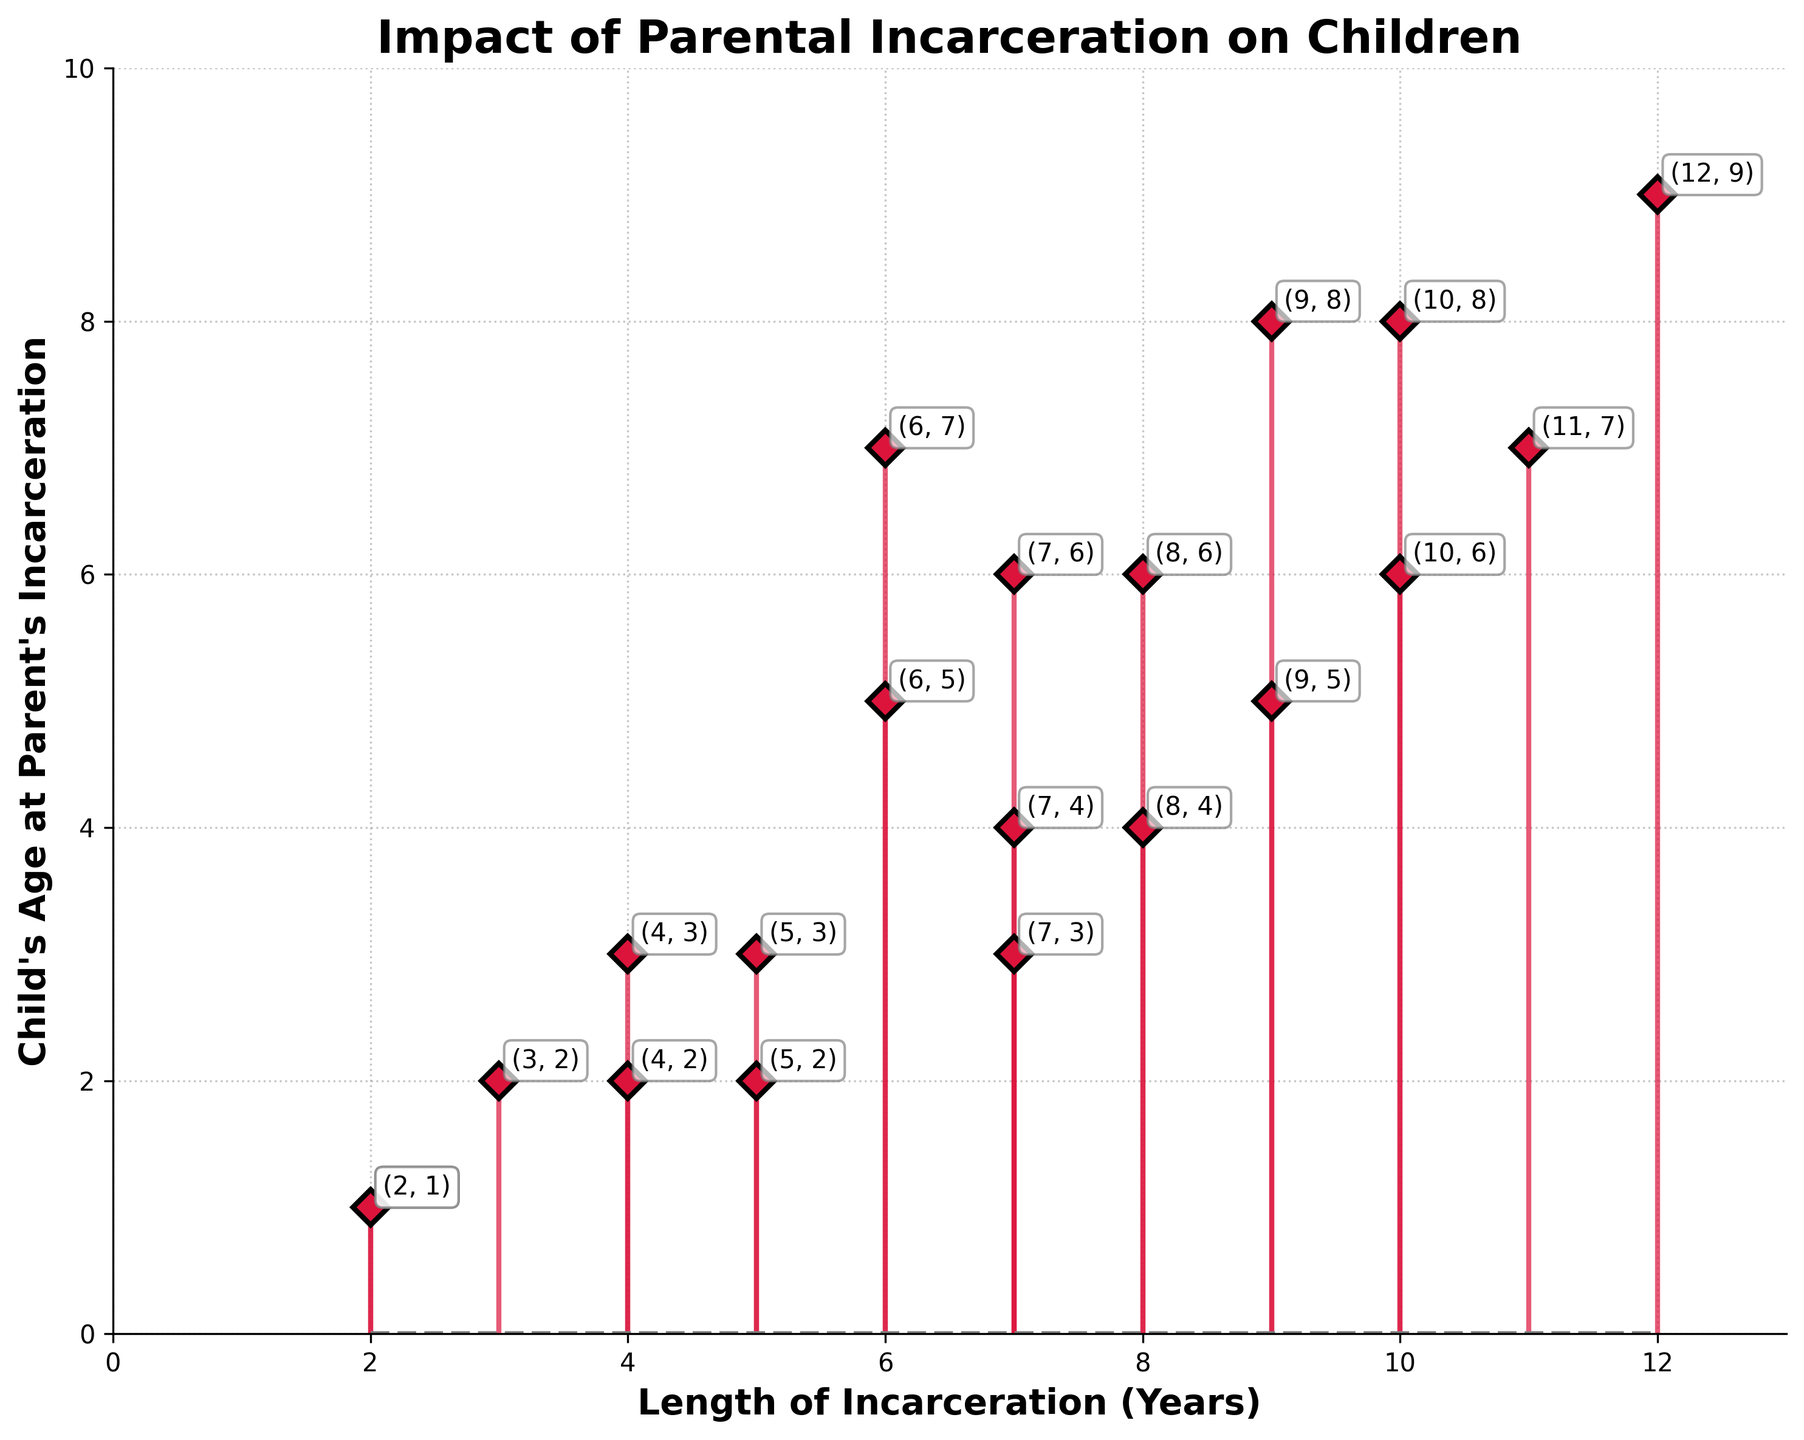How many data points are plotted on the figure? By counting the number of stems and markers visible on the figure, we can determine the number of data points. Each stem corresponds to one data point.
Answer: 20 What is the title of the figure? The title of the figure is usually placed at the top and is prominently displayed in bold and larger font size.
Answer: Impact of Parental Incarceration on Children Which axis represents the "Length of Incarceration"? The axis labels usually provide this information. By checking the labels on both axes, we identify that "Length of Incarceration (Years)" is labeled on the horizontal axis.
Answer: Horizontal axis Which has a higher child's age at the time of parent's incarceration, an 8-year or a 6-year incarceration length? By locating the stems corresponding to 8 and 6 on the horizontal axis and reading their values on the vertical axis, we can find that the child's age is higher for 8-year incarceration (6 years) compared to 6-year incarceration (5 years).
Answer: 8-year incarceration What is the child's age when the parent is incarcerated for 12 years? Locate the stem corresponding to "12" on the horizontal axis, then read the value on the vertical axis at the top of that stem to find that the child's age is 9 years.
Answer: 9 years Is there any instance where the child's age at the time of parent's incarceration is the same for two different lengths of incarceration? By carefully inspecting the overlapping points along the vertical axis for different horizontal positions, we find that for lengths of incarceration of 2 and 5 years, the child's age is 1 year for both.
Answer: Yes What is the range of the children's age at the time of parent's incarceration depicted in the figure? To find the range, identify the minimum and maximum values on the vertical axis. The minimum child's age is 1 year, and the maximum is 9 years, so the range is 9 - 1 = 8 years.
Answer: 8 years For which lengths of incarceration are the child's age values annotated as (2, 1)? By identifying and locating the specific annotated text "(2, 1)" on the plot, and noting its horizontal position, we confirm that this annotation appears for the two lengths of 2 years.
Answer: 2 years What is the average child's age at the time of parent's incarceration for incarceration lengths of 7 years? For lengths of incarceration of 7 years, the child's ages are 6, 3, and 4. To calculate the average: (6 + 3 + 4) / 3 = 13 / 3 ≈ 4.33 years.
Answer: 4.33 years 